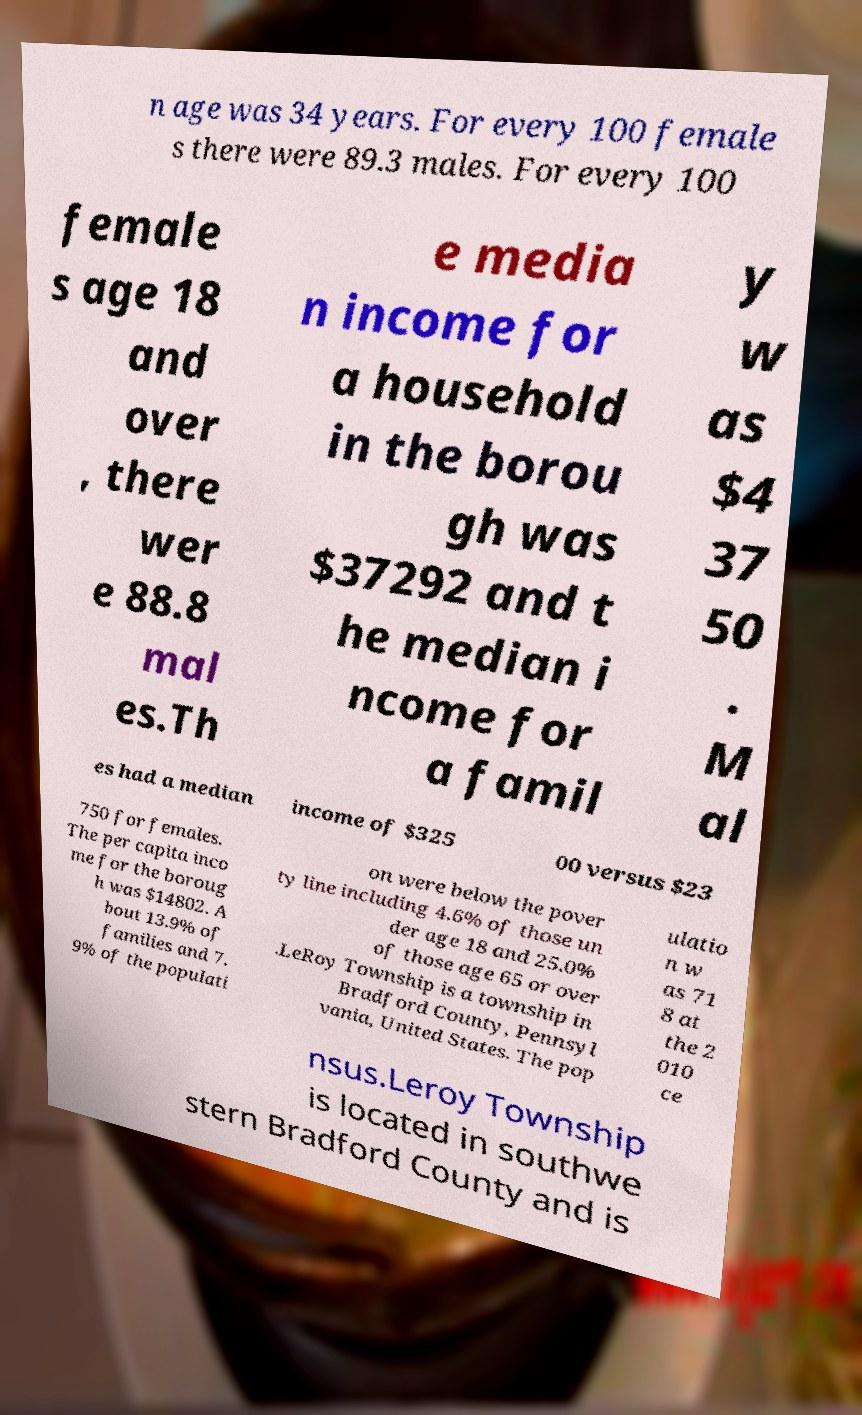Could you assist in decoding the text presented in this image and type it out clearly? n age was 34 years. For every 100 female s there were 89.3 males. For every 100 female s age 18 and over , there wer e 88.8 mal es.Th e media n income for a household in the borou gh was $37292 and t he median i ncome for a famil y w as $4 37 50 . M al es had a median income of $325 00 versus $23 750 for females. The per capita inco me for the boroug h was $14802. A bout 13.9% of families and 7. 9% of the populati on were below the pover ty line including 4.6% of those un der age 18 and 25.0% of those age 65 or over .LeRoy Township is a township in Bradford County, Pennsyl vania, United States. The pop ulatio n w as 71 8 at the 2 010 ce nsus.Leroy Township is located in southwe stern Bradford County and is 